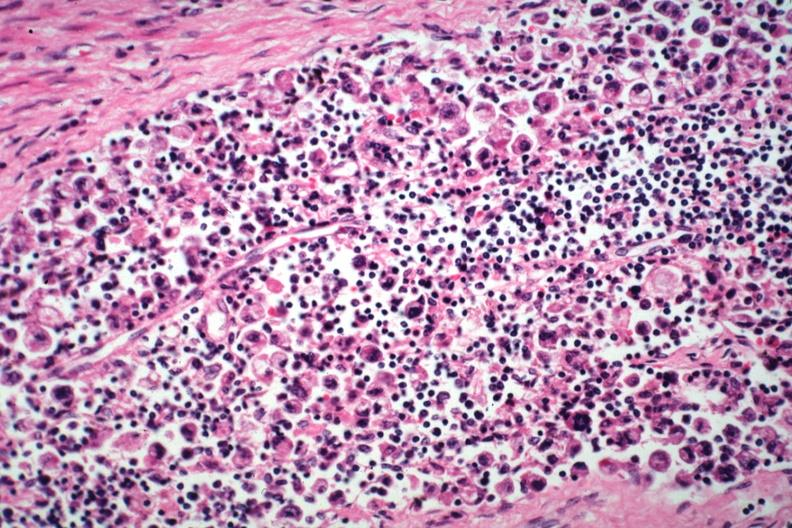what does this image show?
Answer the question using a single word or phrase. Hepatic node anaplastic adenocarcinoma from a one cm sessile prepyloric polyp incidental finding died with promyelocytic leukemia stomach lesion # 